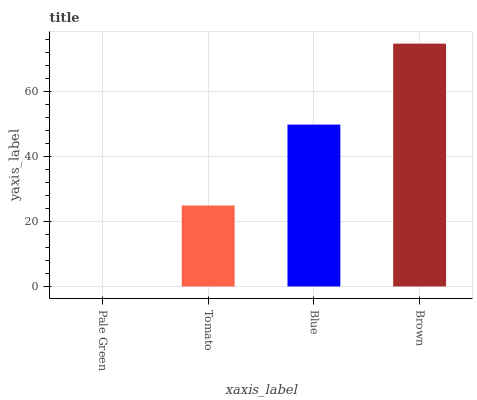Is Pale Green the minimum?
Answer yes or no. Yes. Is Brown the maximum?
Answer yes or no. Yes. Is Tomato the minimum?
Answer yes or no. No. Is Tomato the maximum?
Answer yes or no. No. Is Tomato greater than Pale Green?
Answer yes or no. Yes. Is Pale Green less than Tomato?
Answer yes or no. Yes. Is Pale Green greater than Tomato?
Answer yes or no. No. Is Tomato less than Pale Green?
Answer yes or no. No. Is Blue the high median?
Answer yes or no. Yes. Is Tomato the low median?
Answer yes or no. Yes. Is Brown the high median?
Answer yes or no. No. Is Blue the low median?
Answer yes or no. No. 